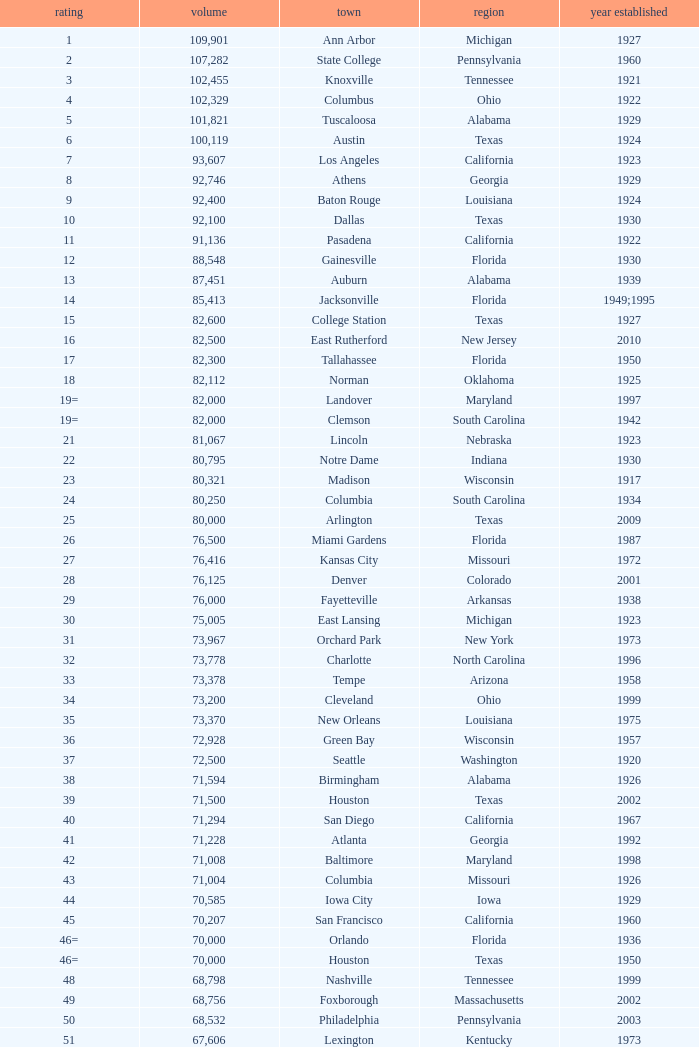What was the year opened for North Carolina with a smaller than 21,500 capacity? 1926.0. 